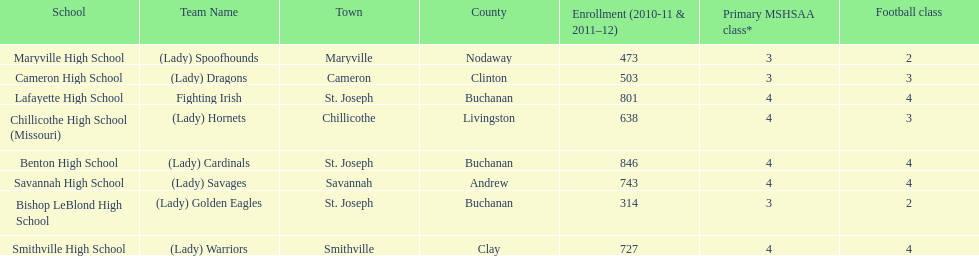How many teams are named after birds? 2. 